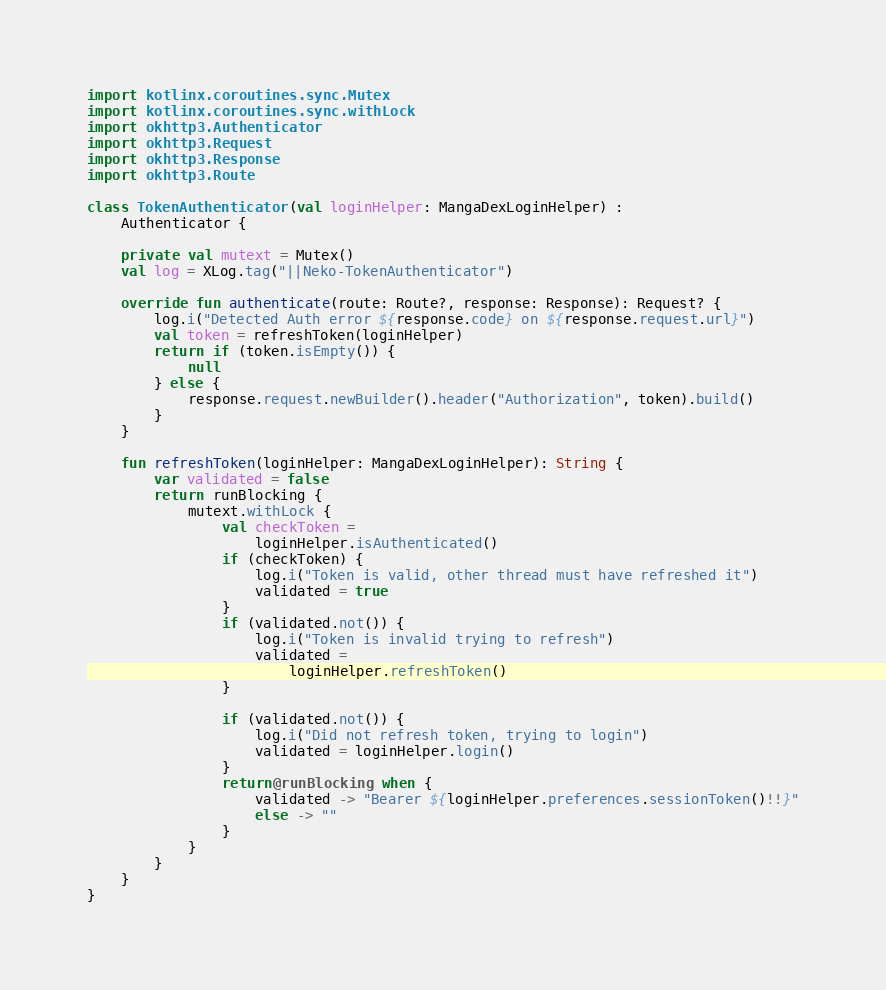<code> <loc_0><loc_0><loc_500><loc_500><_Kotlin_>import kotlinx.coroutines.sync.Mutex
import kotlinx.coroutines.sync.withLock
import okhttp3.Authenticator
import okhttp3.Request
import okhttp3.Response
import okhttp3.Route

class TokenAuthenticator(val loginHelper: MangaDexLoginHelper) :
    Authenticator {

    private val mutext = Mutex()
    val log = XLog.tag("||Neko-TokenAuthenticator")

    override fun authenticate(route: Route?, response: Response): Request? {
        log.i("Detected Auth error ${response.code} on ${response.request.url}")
        val token = refreshToken(loginHelper)
        return if (token.isEmpty()) {
            null
        } else {
            response.request.newBuilder().header("Authorization", token).build()
        }
    }

    fun refreshToken(loginHelper: MangaDexLoginHelper): String {
        var validated = false
        return runBlocking {
            mutext.withLock {
                val checkToken =
                    loginHelper.isAuthenticated()
                if (checkToken) {
                    log.i("Token is valid, other thread must have refreshed it")
                    validated = true
                }
                if (validated.not()) {
                    log.i("Token is invalid trying to refresh")
                    validated =
                        loginHelper.refreshToken()
                }

                if (validated.not()) {
                    log.i("Did not refresh token, trying to login")
                    validated = loginHelper.login()
                }
                return@runBlocking when {
                    validated -> "Bearer ${loginHelper.preferences.sessionToken()!!}"
                    else -> ""
                }
            }
        }
    }
}
</code> 